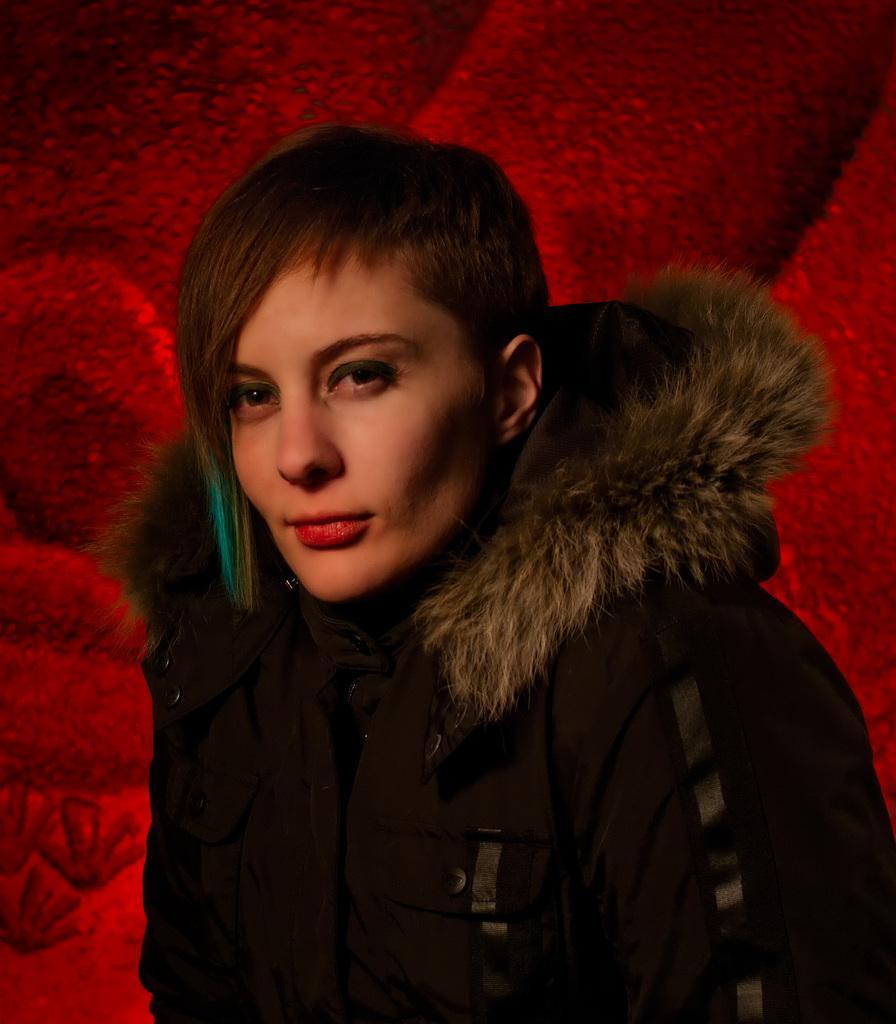Can you describe this image briefly? In the center of the image we can see a person wearing a jacket. 